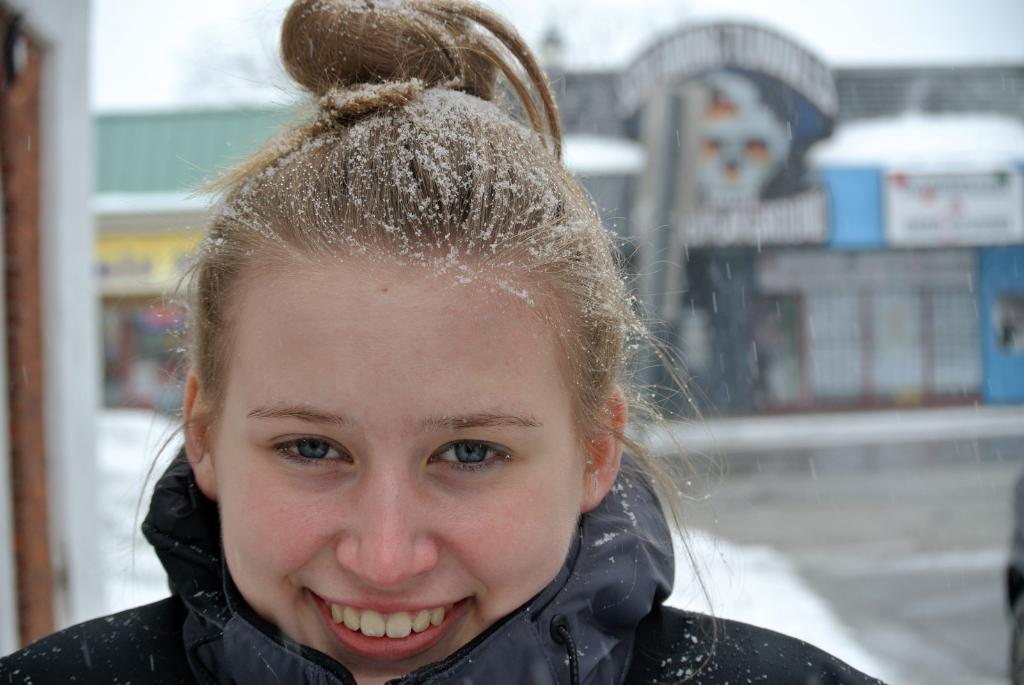Who is present in the image? There is a woman in the image. What is the woman doing in the image? The woman is smiling in the image. What is the woman wearing in the image? The woman is wearing a black dress in the image. What can be seen in the background of the image? There are buildings and snow visible in the background of the image. What is the color of the sky in the image? The sky is white in color in the image. Where is the kettle located in the image? There is no kettle present in the image. Can you see any chickens in the image? There are no chickens present in the image. 